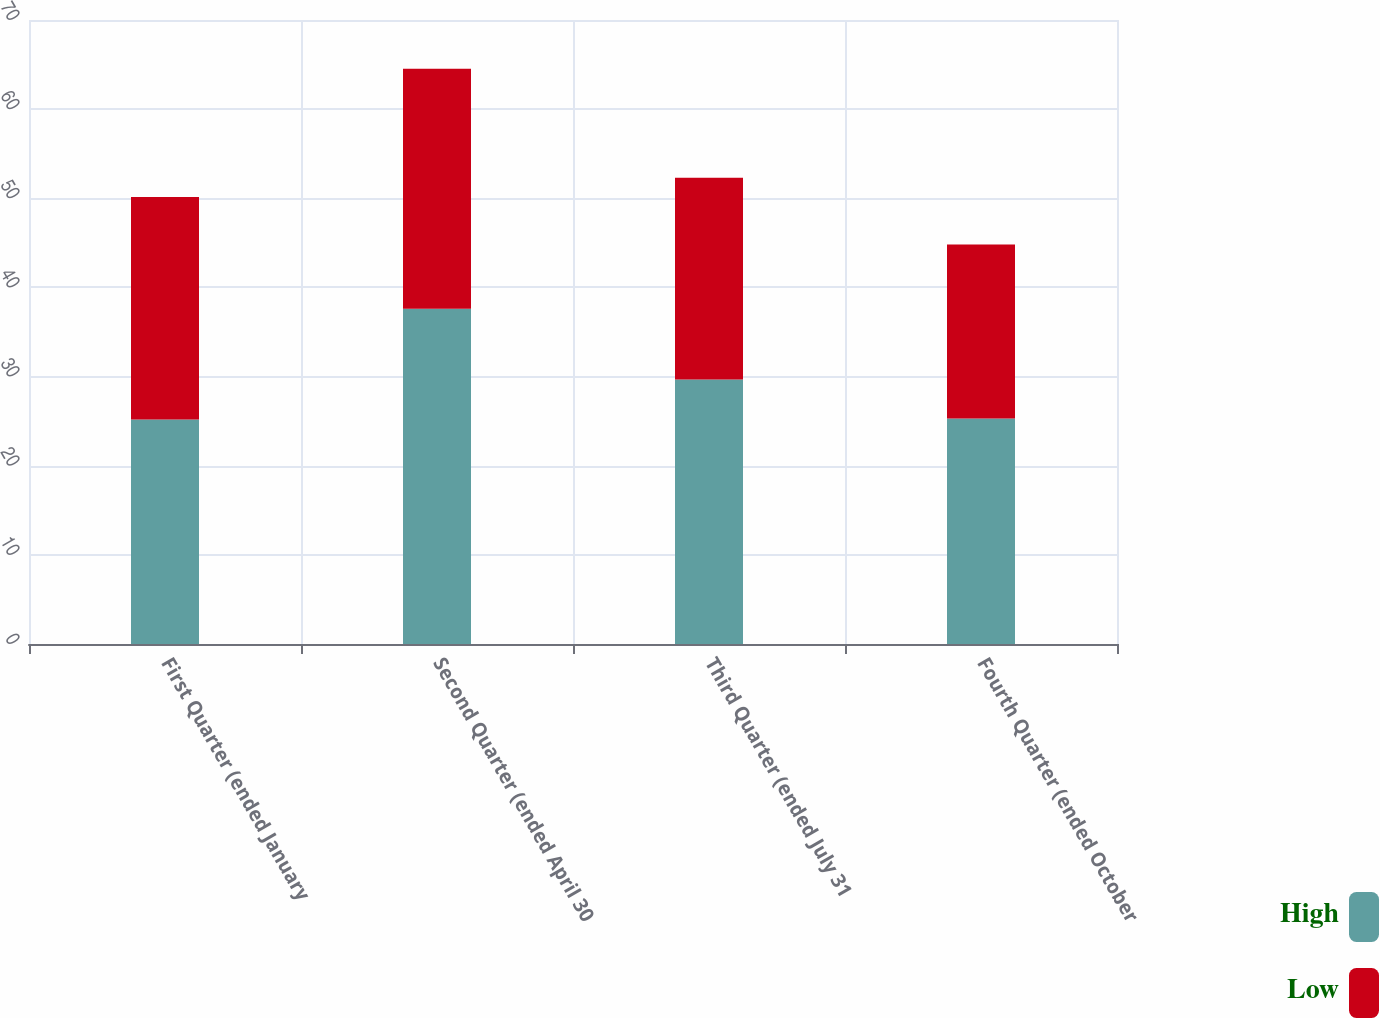<chart> <loc_0><loc_0><loc_500><loc_500><stacked_bar_chart><ecel><fcel>First Quarter (ended January<fcel>Second Quarter (ended April 30<fcel>Third Quarter (ended July 31<fcel>Fourth Quarter (ended October<nl><fcel>High<fcel>25.18<fcel>37.62<fcel>29.68<fcel>25.31<nl><fcel>Low<fcel>24.97<fcel>26.91<fcel>22.63<fcel>19.51<nl></chart> 